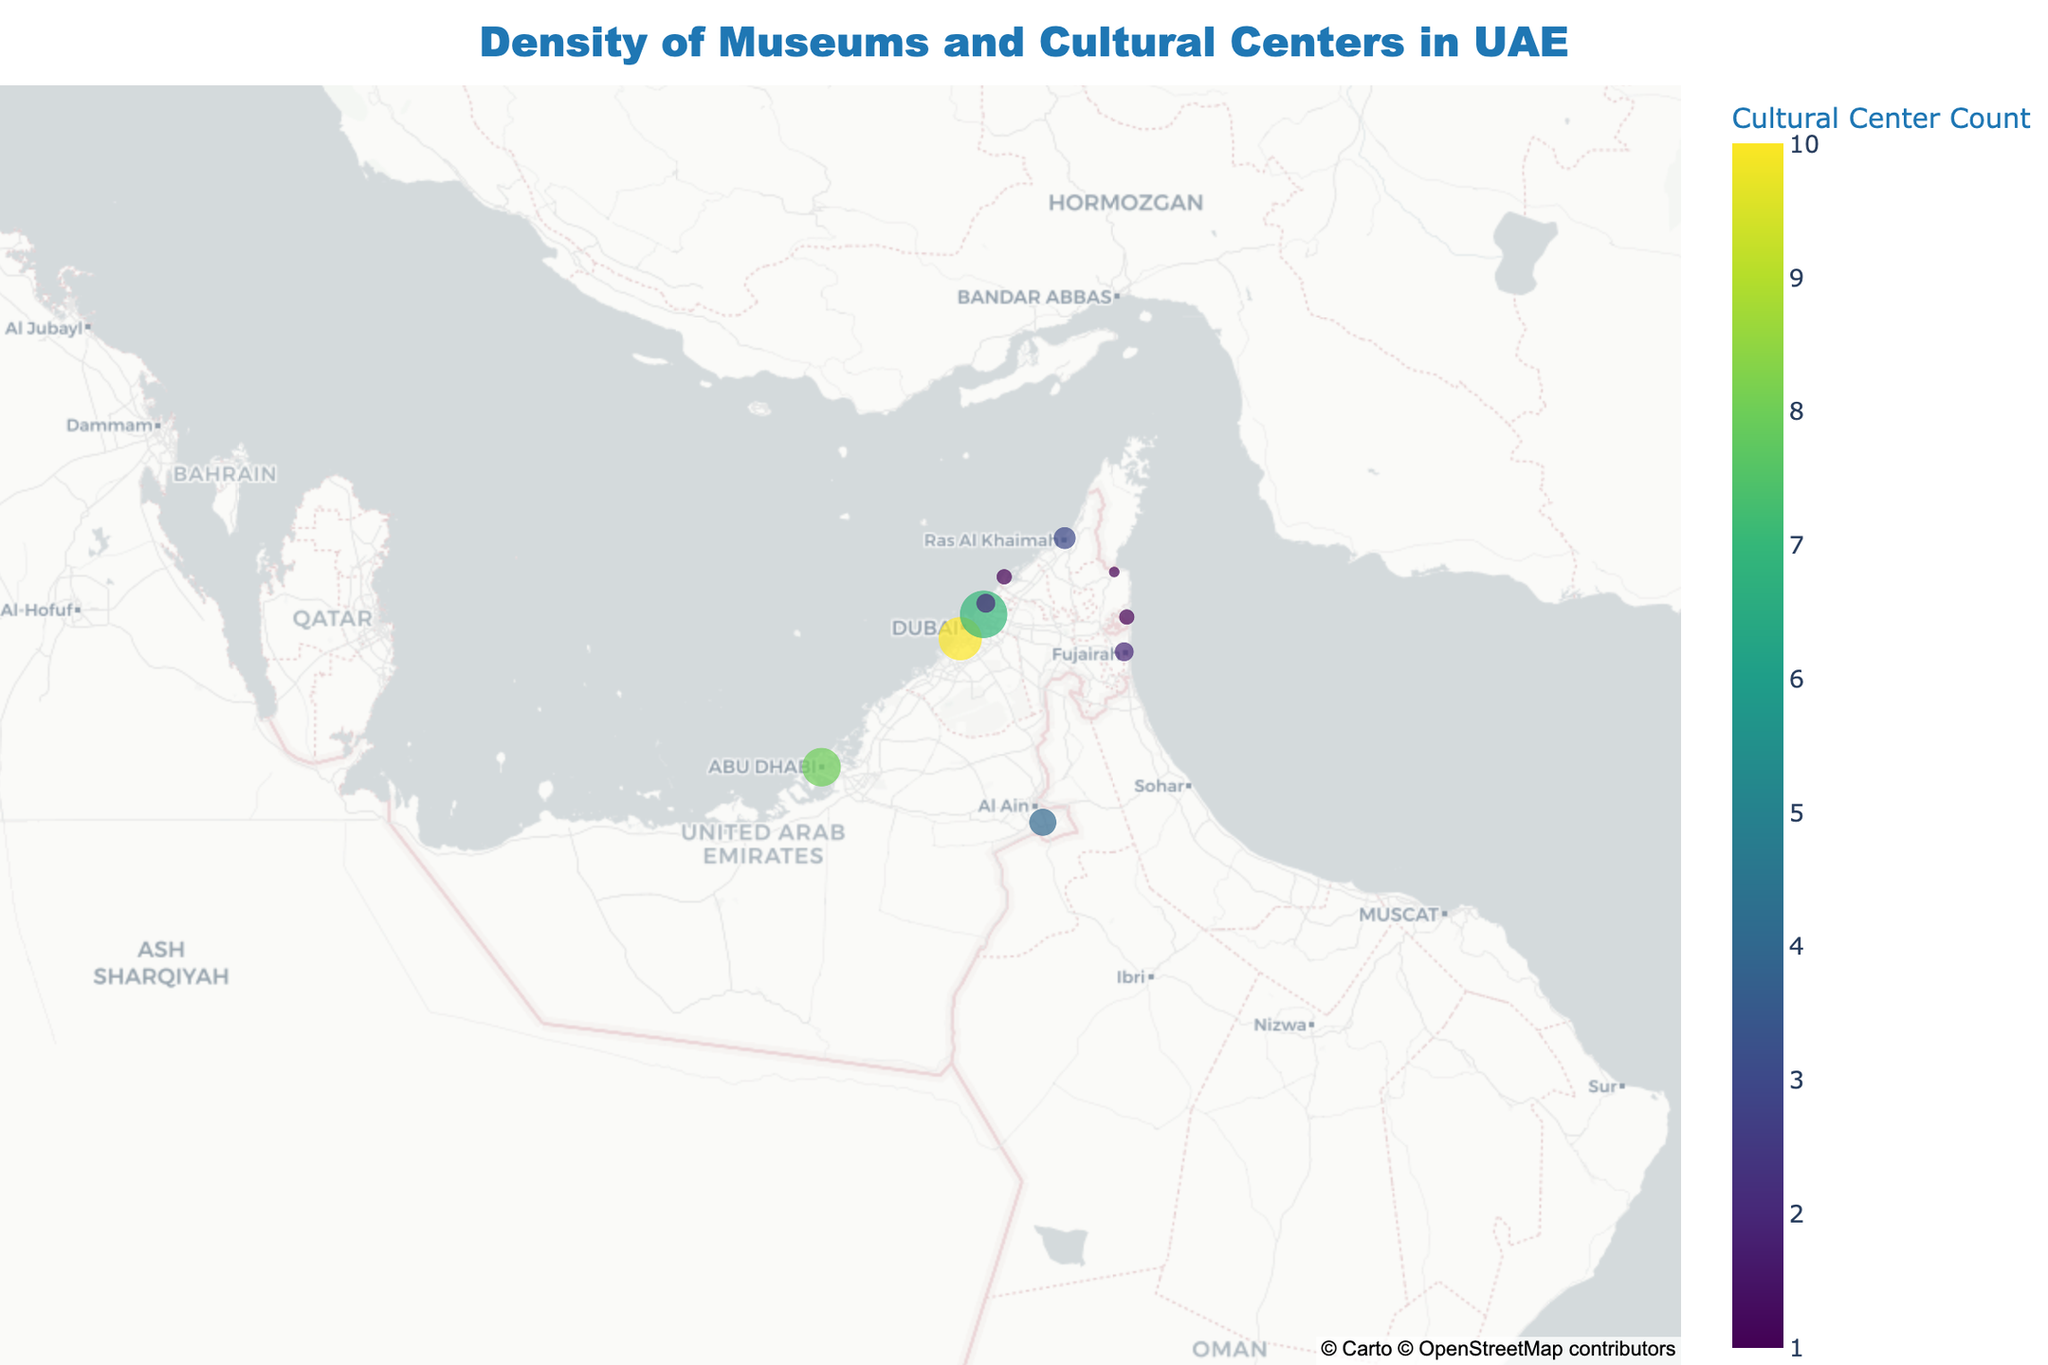How many cities are represented for the Emirate of Sharjah? Inspect the figure for city markers within the Emirate of Sharjah. You should count two city markers: "Sharjah" and "Khor Fakkan."
Answer: 2 Which city has the highest count of museums? By observing the size of the markers, the city with the largest marker represents the highest count of museums, which is "Sharjah."
Answer: Sharjah How does the count of cultural centers in Dubai compare to the count in Abu Dhabi? Examine both the color and legend of markers for Dubai and Abu Dhabi. The color represents the count of cultural centers, with Dubai having 10 and Abu Dhabi 8.
Answer: Dubai has 2 more cultural centers than Abu Dhabi Which city has the lowest density of cultural centers and museums combined? Check the hover text of each marker to sum the counts of museums and cultural centers. The city with the smallest sum is "Dibba," with 1 museum and 1 cultural center.
Answer: Dibba What is the total number of museums in the UAE? Sum the counts of museums for all cities from the hover information. That is 12 (Abu Dhabi) + 15 (Dubai) + 18 (Sharjah) + 4 (Ras Al Khaimah) + 3 (Fujairah) + 2 (Umm Al Quwain) + 3 (Ajman) + 6 (Al Ain) + 2 (Khor Fakkan) + 1 (Dibba) = 66.
Answer: 66 What is the average count of cultural centers per city? Add the number of cultural centers for each city, then divide by the number of cities: (8+10+7+3+2+1+2+4+1+1)/10 = 3.9.
Answer: 3.9 Which emirate has cities with the most varied density of museums and cultural centers? Check the figure for variance by looking at the differences in marker size and color within each Emirate. "Sharjah" shows the most variance with Sharjah city and Khor Fakkan having high and low counts, respectively.
Answer: Sharjah In which city do museums far outnumber cultural centers? Find a city with a significant size marker but relatively low color gradient. Abu Dhabi fits, with 12 museums and only 8 cultural centers.
Answer: Abu Dhabi 